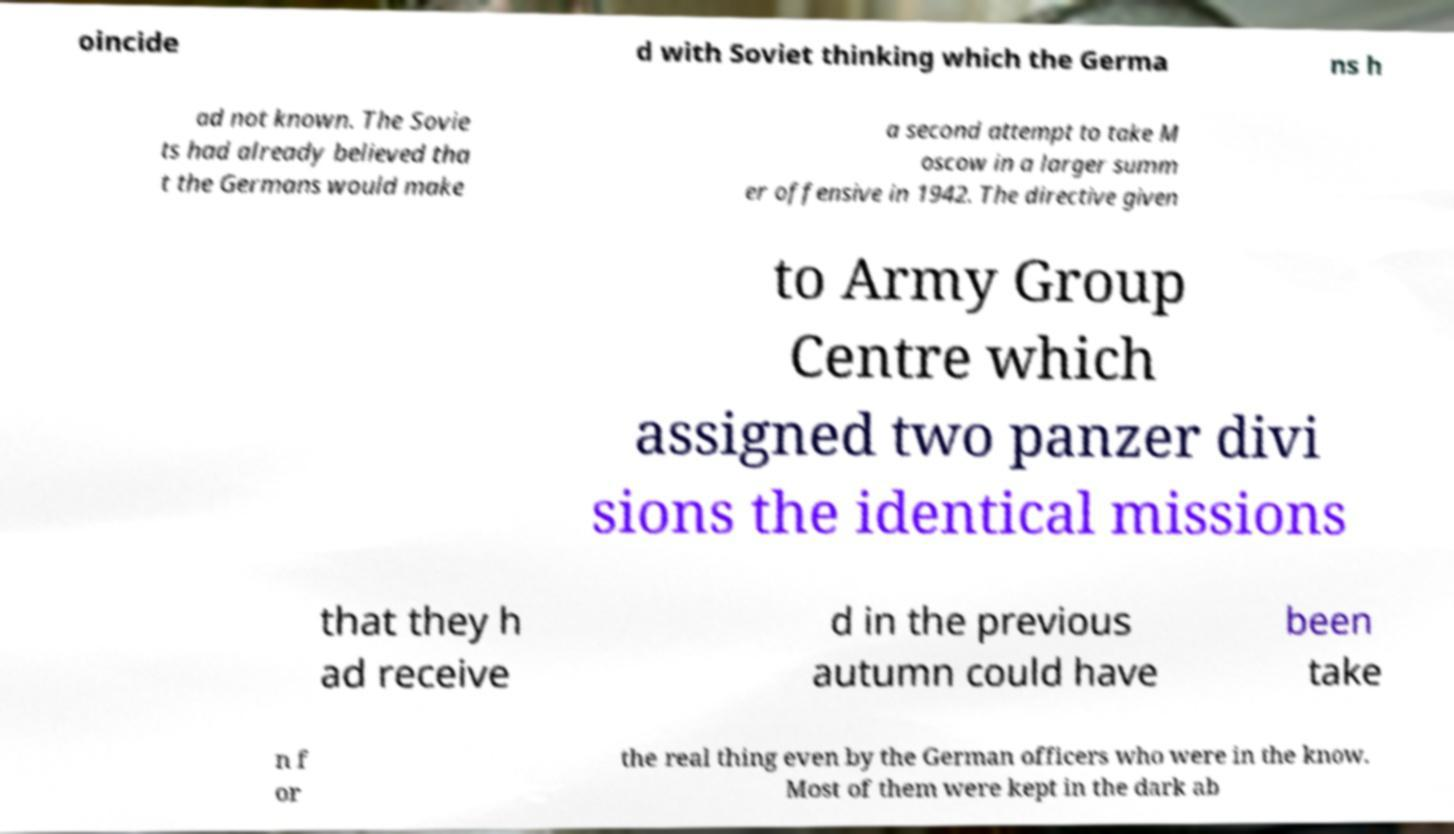Could you assist in decoding the text presented in this image and type it out clearly? oincide d with Soviet thinking which the Germa ns h ad not known. The Sovie ts had already believed tha t the Germans would make a second attempt to take M oscow in a larger summ er offensive in 1942. The directive given to Army Group Centre which assigned two panzer divi sions the identical missions that they h ad receive d in the previous autumn could have been take n f or the real thing even by the German officers who were in the know. Most of them were kept in the dark ab 